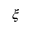Convert formula to latex. <formula><loc_0><loc_0><loc_500><loc_500>\xi</formula> 